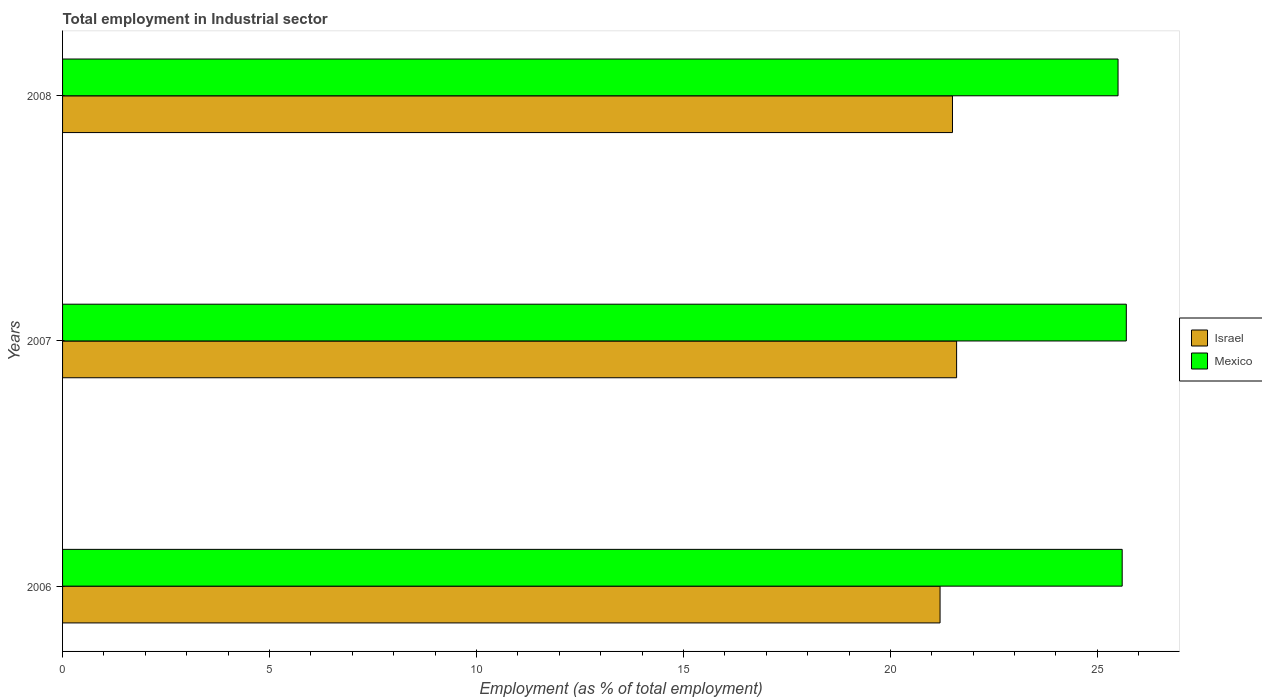How many groups of bars are there?
Ensure brevity in your answer.  3. Are the number of bars on each tick of the Y-axis equal?
Your answer should be very brief. Yes. How many bars are there on the 2nd tick from the bottom?
Your response must be concise. 2. What is the employment in industrial sector in Israel in 2007?
Provide a short and direct response. 21.6. Across all years, what is the maximum employment in industrial sector in Israel?
Offer a very short reply. 21.6. Across all years, what is the minimum employment in industrial sector in Israel?
Provide a short and direct response. 21.2. In which year was the employment in industrial sector in Israel minimum?
Provide a succinct answer. 2006. What is the total employment in industrial sector in Mexico in the graph?
Keep it short and to the point. 76.8. What is the difference between the employment in industrial sector in Mexico in 2006 and that in 2007?
Make the answer very short. -0.1. What is the difference between the employment in industrial sector in Mexico in 2006 and the employment in industrial sector in Israel in 2008?
Provide a succinct answer. 4.1. What is the average employment in industrial sector in Mexico per year?
Offer a terse response. 25.6. In how many years, is the employment in industrial sector in Mexico greater than 20 %?
Your answer should be very brief. 3. What is the ratio of the employment in industrial sector in Mexico in 2007 to that in 2008?
Keep it short and to the point. 1.01. Is the employment in industrial sector in Mexico in 2006 less than that in 2008?
Offer a terse response. No. What is the difference between the highest and the second highest employment in industrial sector in Mexico?
Offer a terse response. 0.1. What is the difference between the highest and the lowest employment in industrial sector in Israel?
Your answer should be compact. 0.4. What does the 1st bar from the top in 2007 represents?
Give a very brief answer. Mexico. How many years are there in the graph?
Keep it short and to the point. 3. Are the values on the major ticks of X-axis written in scientific E-notation?
Make the answer very short. No. Does the graph contain any zero values?
Provide a succinct answer. No. Does the graph contain grids?
Ensure brevity in your answer.  No. Where does the legend appear in the graph?
Your answer should be compact. Center right. How are the legend labels stacked?
Your answer should be compact. Vertical. What is the title of the graph?
Give a very brief answer. Total employment in Industrial sector. What is the label or title of the X-axis?
Your answer should be compact. Employment (as % of total employment). What is the Employment (as % of total employment) of Israel in 2006?
Offer a very short reply. 21.2. What is the Employment (as % of total employment) of Mexico in 2006?
Ensure brevity in your answer.  25.6. What is the Employment (as % of total employment) of Israel in 2007?
Ensure brevity in your answer.  21.6. What is the Employment (as % of total employment) in Mexico in 2007?
Provide a succinct answer. 25.7. What is the Employment (as % of total employment) of Israel in 2008?
Ensure brevity in your answer.  21.5. What is the Employment (as % of total employment) of Mexico in 2008?
Your answer should be very brief. 25.5. Across all years, what is the maximum Employment (as % of total employment) of Israel?
Your answer should be very brief. 21.6. Across all years, what is the maximum Employment (as % of total employment) in Mexico?
Offer a terse response. 25.7. Across all years, what is the minimum Employment (as % of total employment) of Israel?
Make the answer very short. 21.2. What is the total Employment (as % of total employment) of Israel in the graph?
Provide a succinct answer. 64.3. What is the total Employment (as % of total employment) in Mexico in the graph?
Provide a short and direct response. 76.8. What is the difference between the Employment (as % of total employment) in Mexico in 2006 and that in 2007?
Your response must be concise. -0.1. What is the difference between the Employment (as % of total employment) of Mexico in 2006 and that in 2008?
Your response must be concise. 0.1. What is the average Employment (as % of total employment) in Israel per year?
Provide a succinct answer. 21.43. What is the average Employment (as % of total employment) of Mexico per year?
Ensure brevity in your answer.  25.6. In the year 2006, what is the difference between the Employment (as % of total employment) of Israel and Employment (as % of total employment) of Mexico?
Offer a very short reply. -4.4. In the year 2007, what is the difference between the Employment (as % of total employment) in Israel and Employment (as % of total employment) in Mexico?
Ensure brevity in your answer.  -4.1. What is the ratio of the Employment (as % of total employment) of Israel in 2006 to that in 2007?
Your answer should be compact. 0.98. What is the ratio of the Employment (as % of total employment) of Mexico in 2007 to that in 2008?
Your answer should be very brief. 1.01. 